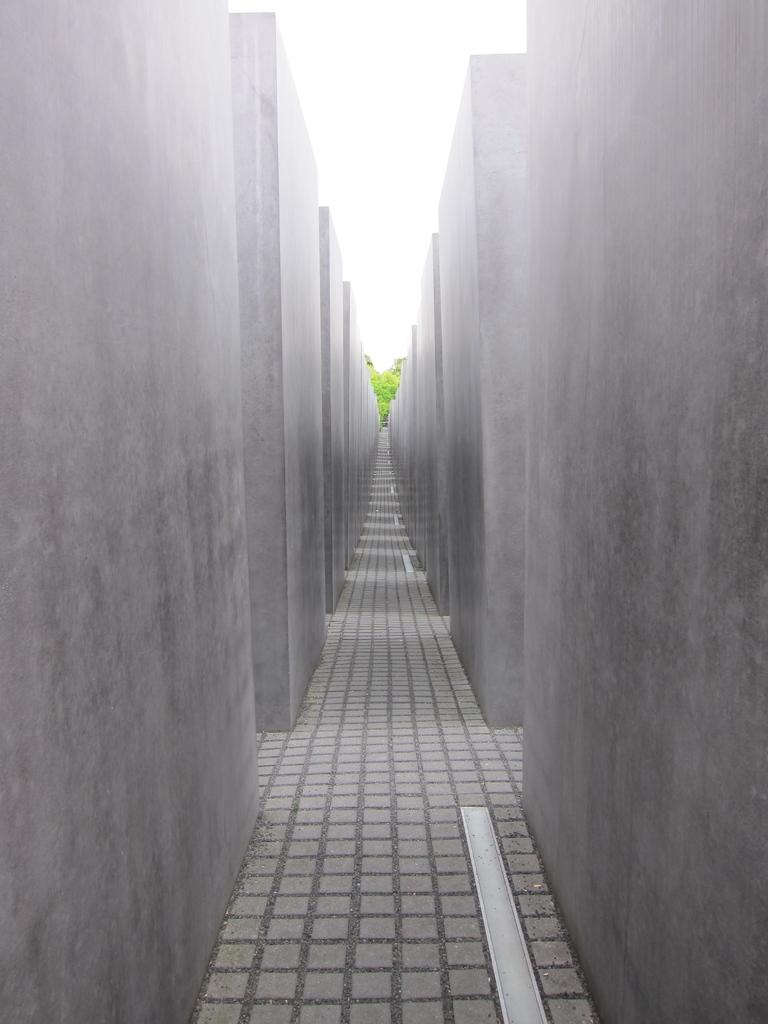What type of space is depicted in the image? There is a corridor in the image. What can be seen on the sides of the corridor? There are walls on the sides of the corridor. What color object is visible in the background of the image? There is a green color object in the background of the image. Where is the faucet located in the image? There is no faucet present in the image. What type of sound can be heard from the bells in the image? There are no bells present in the image, so it is not possible to determine the type of sound they might make. 